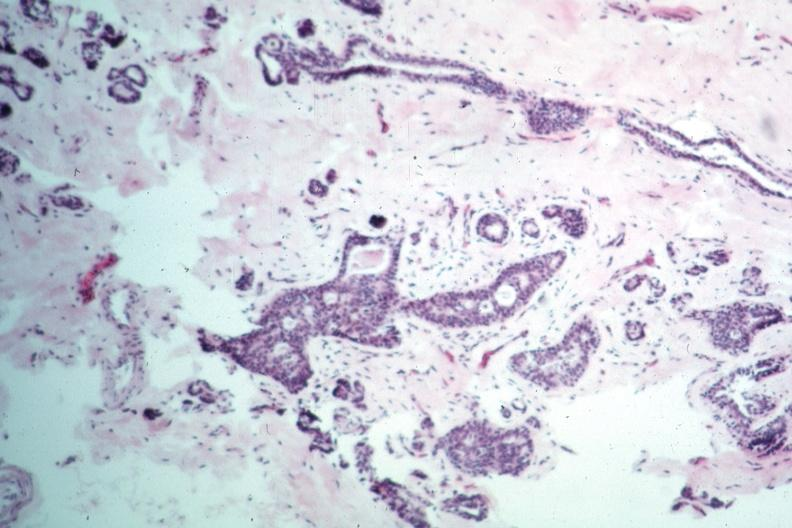does this typical lesion appear benign?
Answer the question using a single word or phrase. Yes 